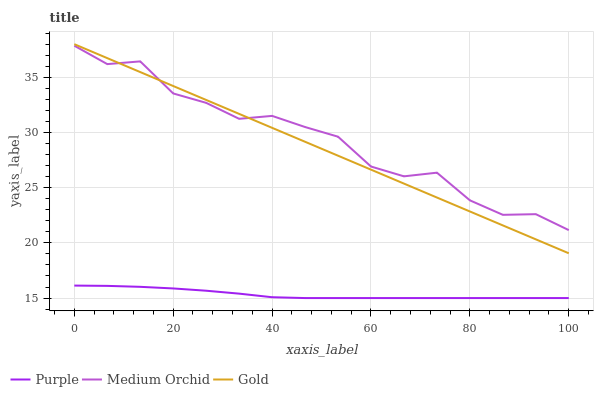Does Gold have the minimum area under the curve?
Answer yes or no. No. Does Gold have the maximum area under the curve?
Answer yes or no. No. Is Medium Orchid the smoothest?
Answer yes or no. No. Is Gold the roughest?
Answer yes or no. No. Does Gold have the lowest value?
Answer yes or no. No. Does Medium Orchid have the highest value?
Answer yes or no. No. Is Purple less than Medium Orchid?
Answer yes or no. Yes. Is Gold greater than Purple?
Answer yes or no. Yes. Does Purple intersect Medium Orchid?
Answer yes or no. No. 